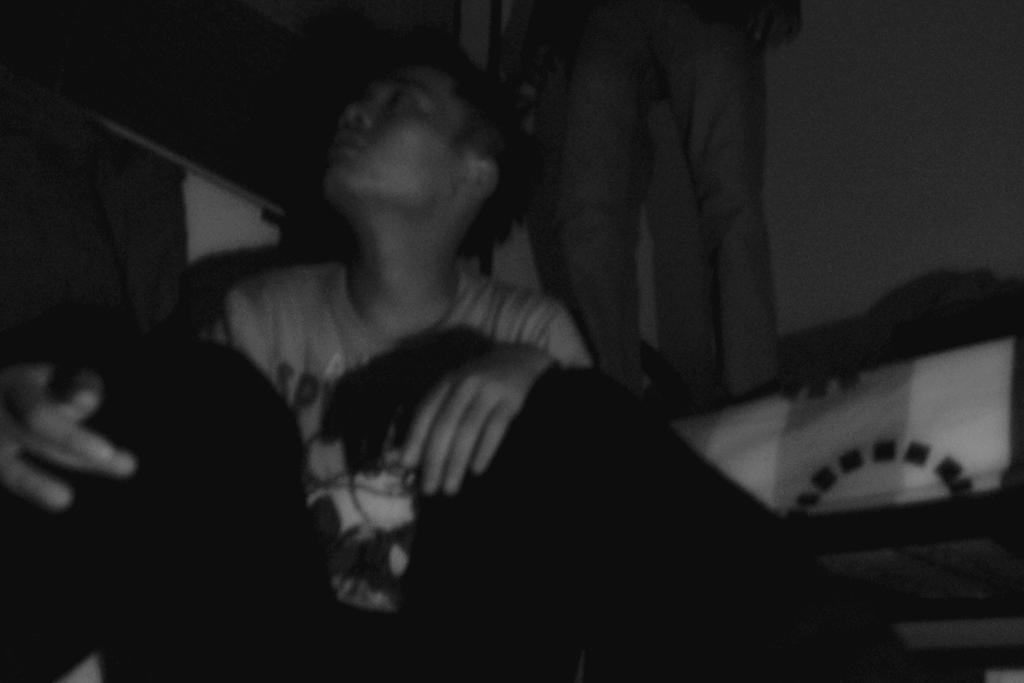What is the color scheme of the image? The image is black and white. What are the people in the image doing? There are people sitting and standing in the image. What can be seen in the background of the image? There is a wall in the background of the image. What color is the cloth visible in the image? The cloth visible in the image is white. How many bells can be heard ringing in the image? There are no bells present in the image, so it is not possible to hear any ringing. 